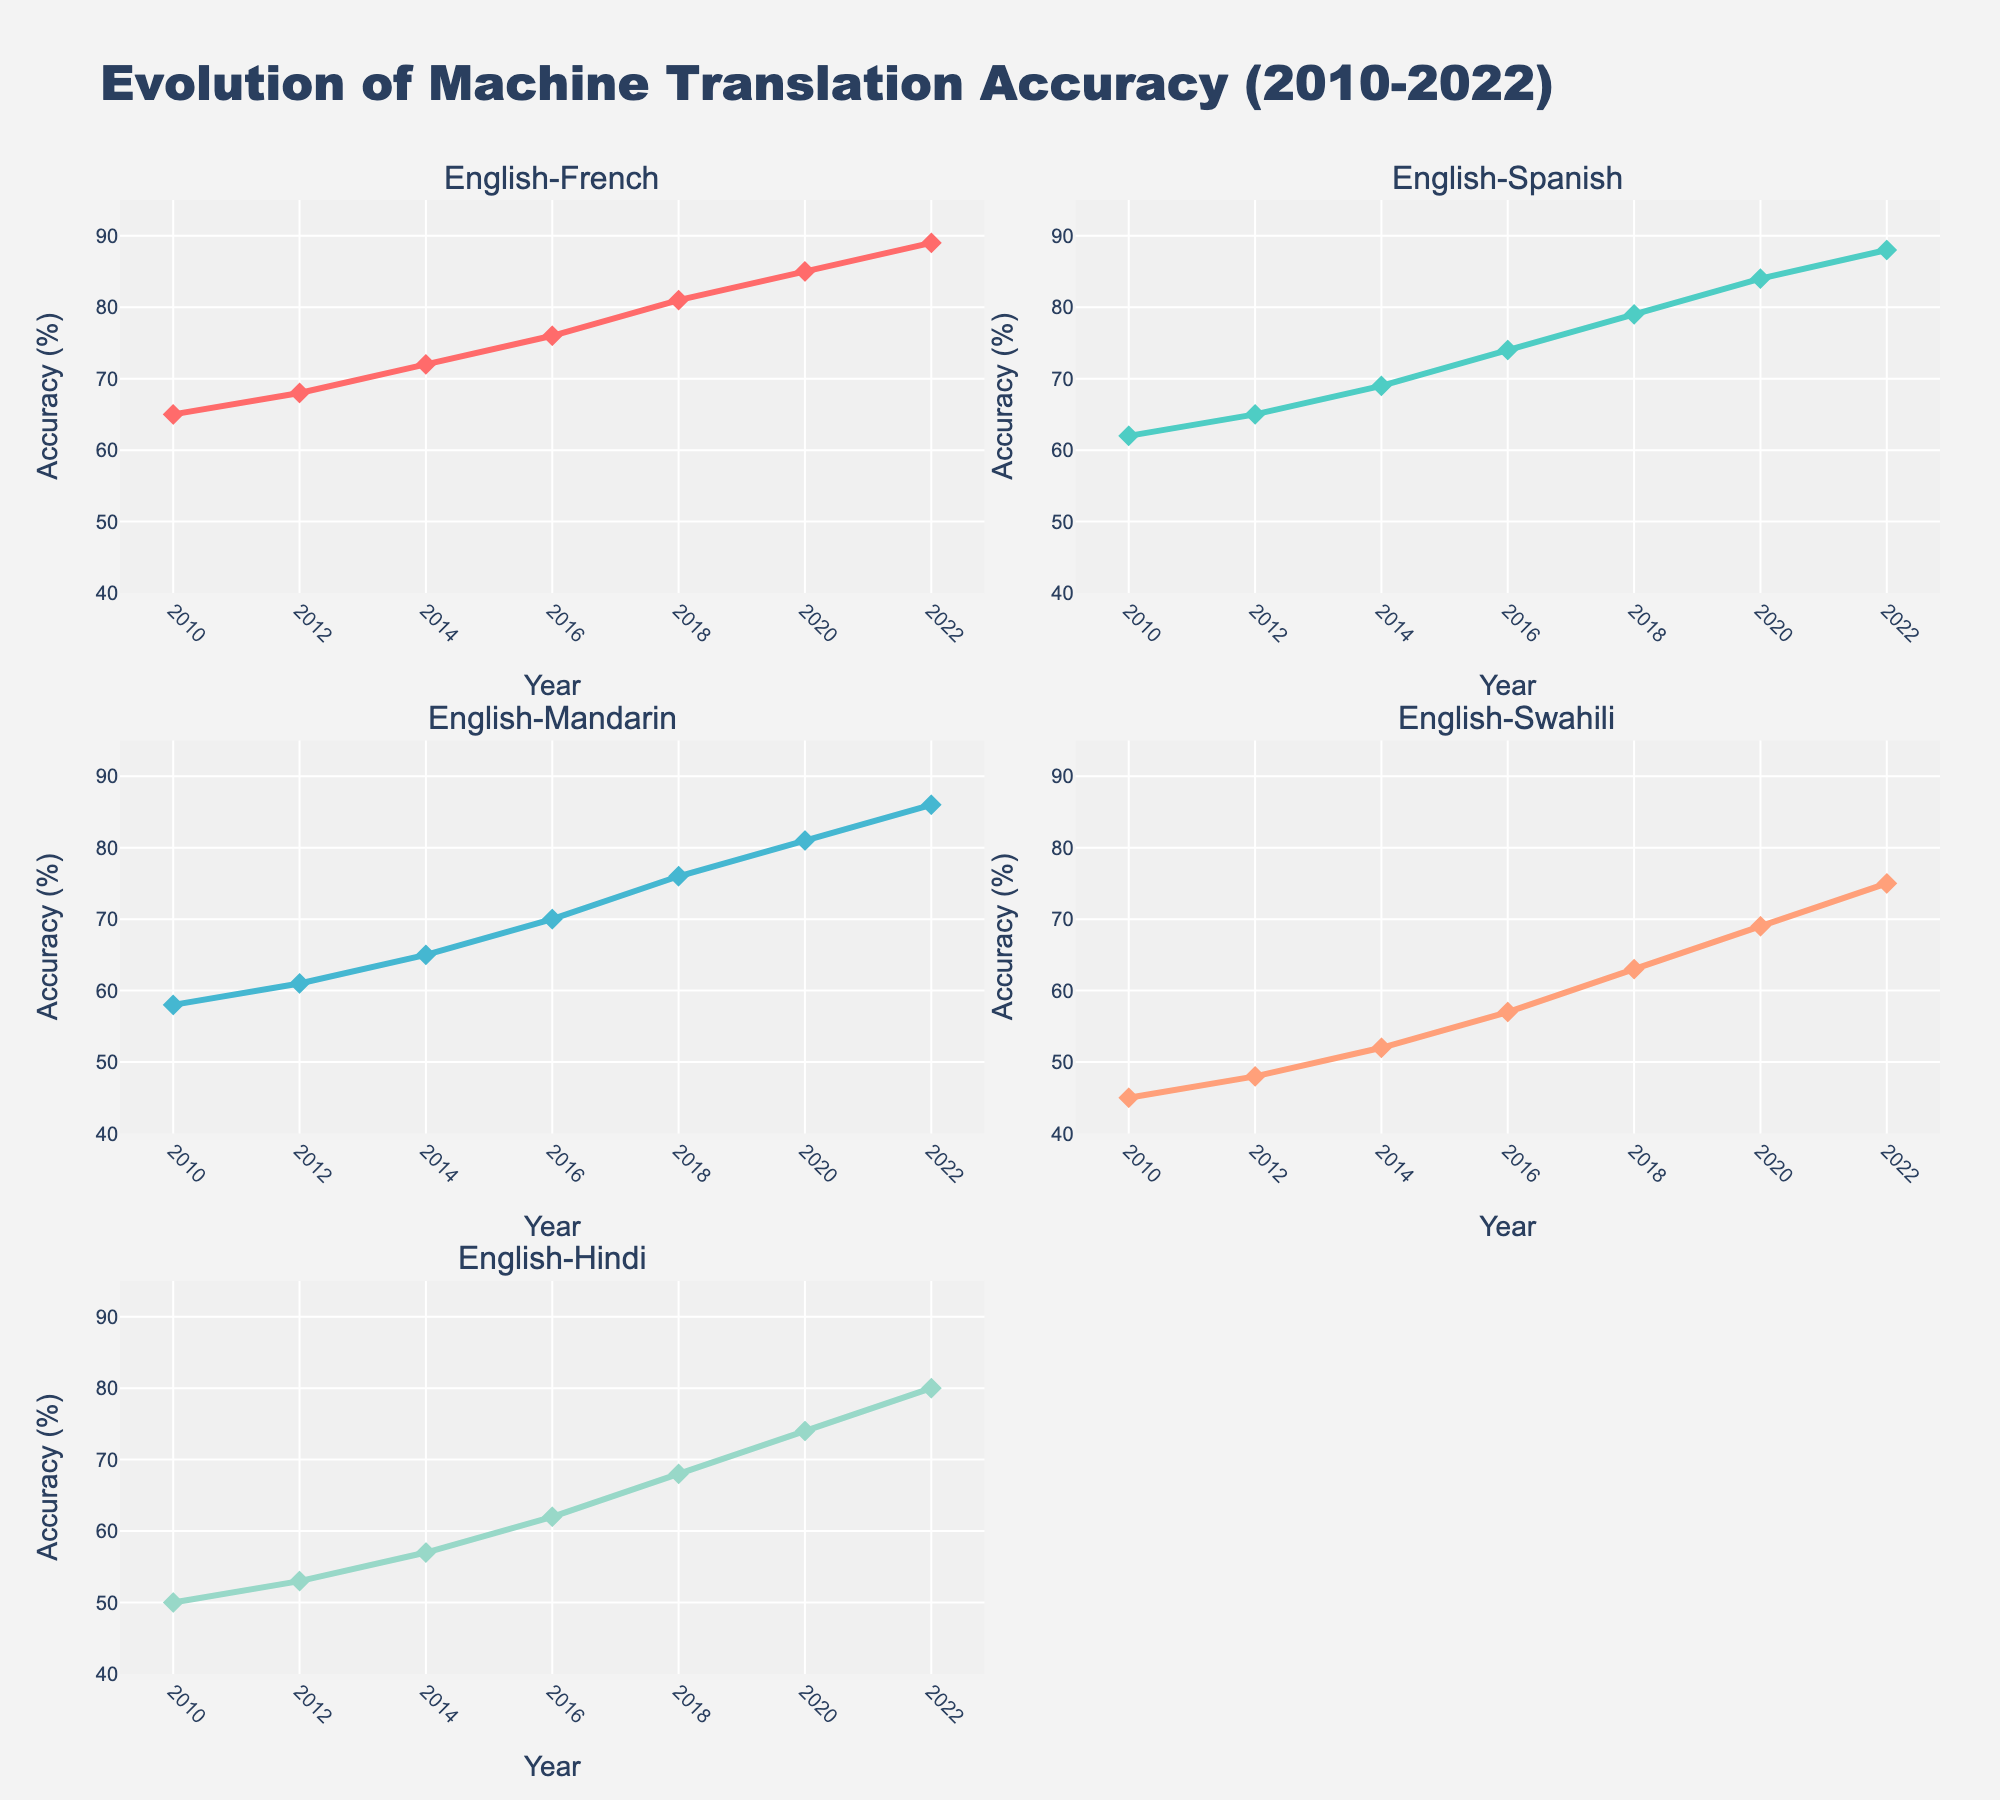Which language pair had the highest translation accuracy in 2022? To find the highest translation accuracy in 2022, look at the last data points in all subplots. The highest value reaching close to 89% is for English-French.
Answer: English-French What is the trend for English-Mandarin translation accuracy from 2010 to 2022? Evaluating the English-Mandarin subplot, the accuracy increases steadily from 2010 (58%) to 2022 (86%).
Answer: Increasing In which year did the English-Swahili translation accuracy first exceed 60%? Check the English-Swahili subplot and find the year where accuracy surpasses 60%. It first exceeds 60% in 2018 (63%).
Answer: 2018 How many data points are plotted for each language pair? Each subplot represents data from 2010 to 2022 with 2-year intervals, so the number of data points is 7 per language pair.
Answer: 7 Which language pair showed the most significant improvement in translation accuracy from 2010 to 2022? Calculate the difference between 2010 and 2022 values for all language pairs, and identify the pair with the largest increase. English-Mandarin increases by 28% (86 - 58).
Answer: English-Mandarin Compare English-Hindi translation accuracy in 2010 and 2022. By how much did it increase? The English-Hindi subplot shows values of 50 in 2010 and 80 in 2022. The difference is 80 - 50 = 30.
Answer: 30 Which year had the most significant jump in English-French translation accuracy? Look for the largest gap between consecutive points in the English-French subplot. The jump from 2018 (81) to 2020 (85) shows the biggest increase of 4%.
Answer: 2018 to 2020 Which language pair had the lowest accuracy in 2010? Check the first data point in all subplots to find the lowest value in 2010, which is English-Swahili with 45%.
Answer: English-Swahili What is the average translation accuracy of English-Spanish across all years? Sum the accuracy values for English-Spanish across all years and divide by the number of data points: (62 + 65 + 69 + 74 + 79 + 84 + 88)/7 = 73
Answer: 73 Is there any year when English-French and English-Hindi translation accuracies are the same? Compare the values of English-French and English-Hindi across all years. They never share the same value in any year from 2010 to 2022.
Answer: No 